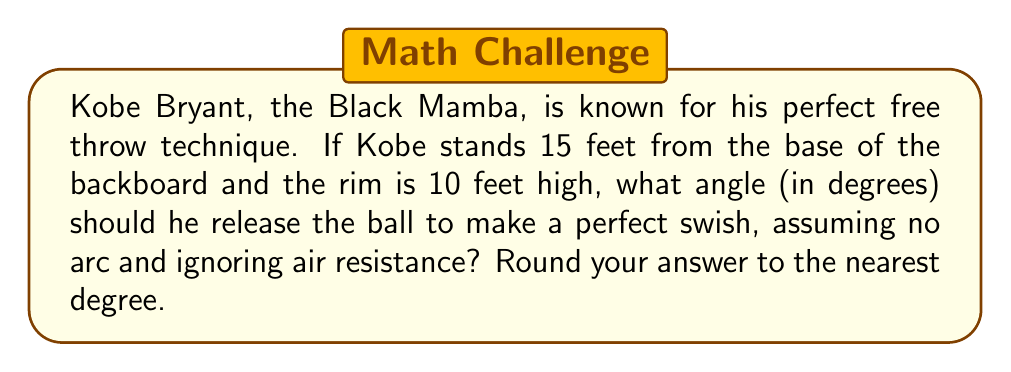Give your solution to this math problem. Let's approach this step-by-step:

1) First, we need to visualize the problem. We can represent this as a right triangle:
   [asy]
   import geometry;
   
   size(200);
   
   pair A = (0,0), B = (15,0), C = (15,10);
   draw(A--B--C--A);
   
   label("15 ft", (7.5,0), S);
   label("10 ft", (15,5), E);
   label("θ", (0,0), NW);
   
   dot("Kobe", A, SW);
   dot("Rim", C, NE);
   [/asy]

2) In this right triangle:
   - The base (adjacent to the angle we're looking for) is 15 feet
   - The height (opposite to the angle) is 10 feet

3) We can use the arctangent function to find the angle. The tangent of an angle in a right triangle is the ratio of the opposite side to the adjacent side.

4) Let θ be the angle we're looking for. Then:

   $$\tan(\theta) = \frac{\text{opposite}}{\text{adjacent}} = \frac{10}{15} = \frac{2}{3}$$

5) To find θ, we take the arctangent (inverse tangent) of both sides:

   $$\theta = \arctan(\frac{2}{3})$$

6) Using a calculator or computer:

   $$\theta \approx 33.69^\circ$$

7) Rounding to the nearest degree:

   $$\theta \approx 34^\circ$$
Answer: $34^\circ$ 